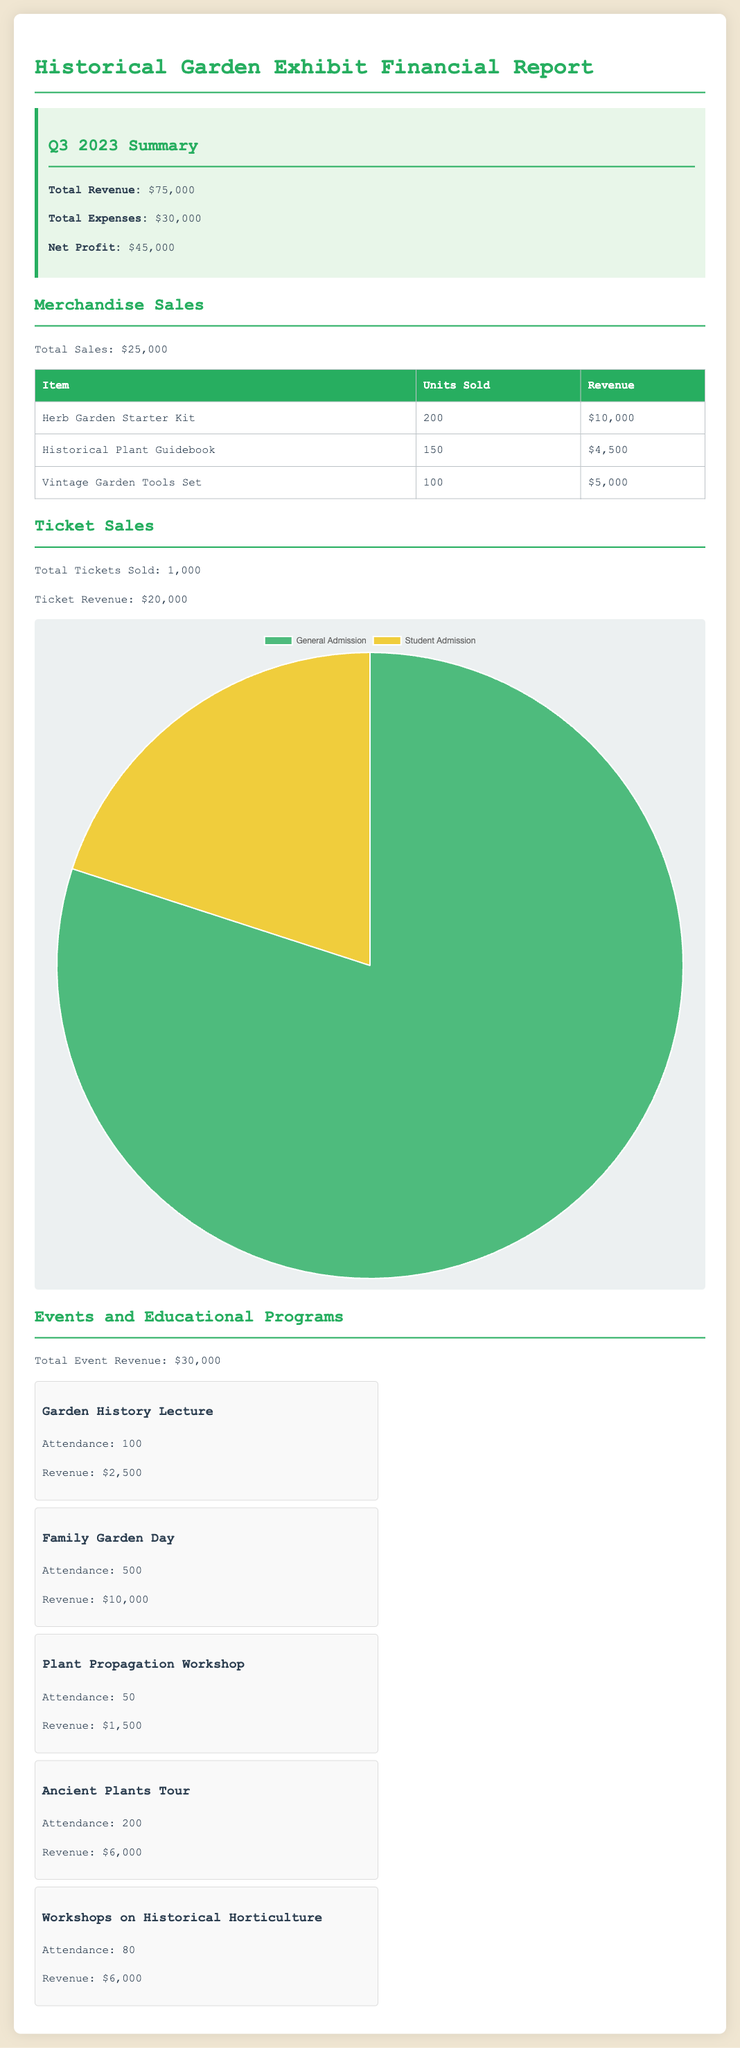What is the total revenue? The total revenue is stated in the summary section of the document.
Answer: $75,000 What was the revenue generated from merchandise sales? The document specifies that merchandise sales generated a total revenue of $25,000.
Answer: $25,000 How many tickets were sold in total? The total tickets sold is explicitly mentioned under the ticket sales section.
Answer: 1,000 What is the total attendance for the Family Garden Day event? The attendance for the Family Garden Day is listed in the events section.
Answer: 500 Which item generated the highest revenue from merchandise sales? The item with the highest revenue is identified in the merchandise sales table.
Answer: Herb Garden Starter Kit What was the revenue from the Garden History Lecture? The revenue for this specific event is provided in the events list.
Answer: $2,500 What is the net profit for Q3 2023? The net profit is calculated as total revenue minus total expenses in the summary.
Answer: $45,000 How much revenue did the Ancient Plants Tour generate? The revenue for this event is noted in the event details section of the document.
Answer: $6,000 What percentage of total revenue came from events and educational programs? This requires adding up the revenue from events and comparing it to total revenue.
Answer: 40% 